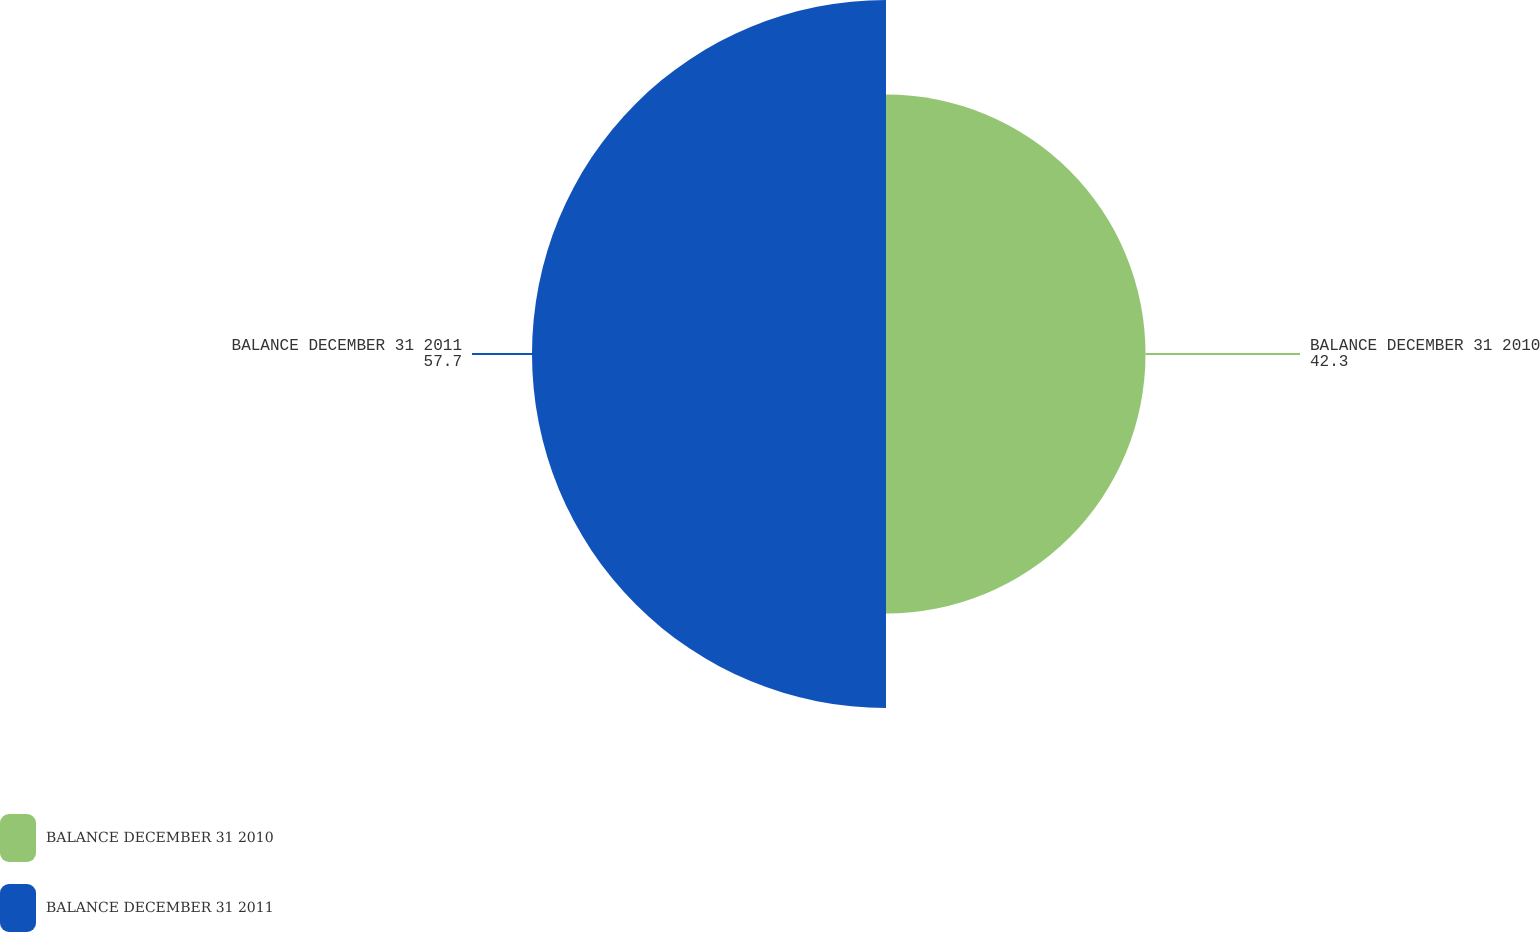Convert chart to OTSL. <chart><loc_0><loc_0><loc_500><loc_500><pie_chart><fcel>BALANCE DECEMBER 31 2010<fcel>BALANCE DECEMBER 31 2011<nl><fcel>42.3%<fcel>57.7%<nl></chart> 